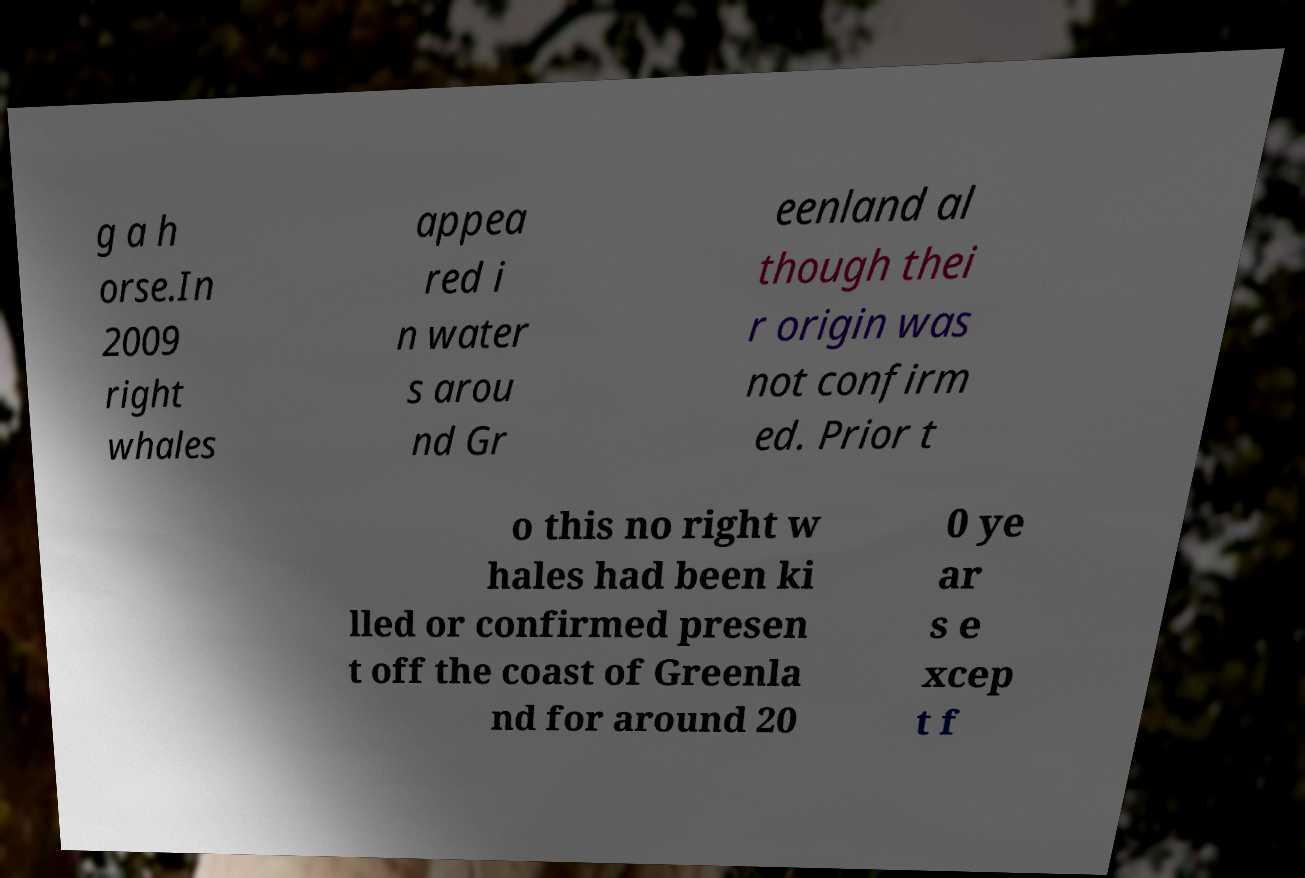Please identify and transcribe the text found in this image. g a h orse.In 2009 right whales appea red i n water s arou nd Gr eenland al though thei r origin was not confirm ed. Prior t o this no right w hales had been ki lled or confirmed presen t off the coast of Greenla nd for around 20 0 ye ar s e xcep t f 